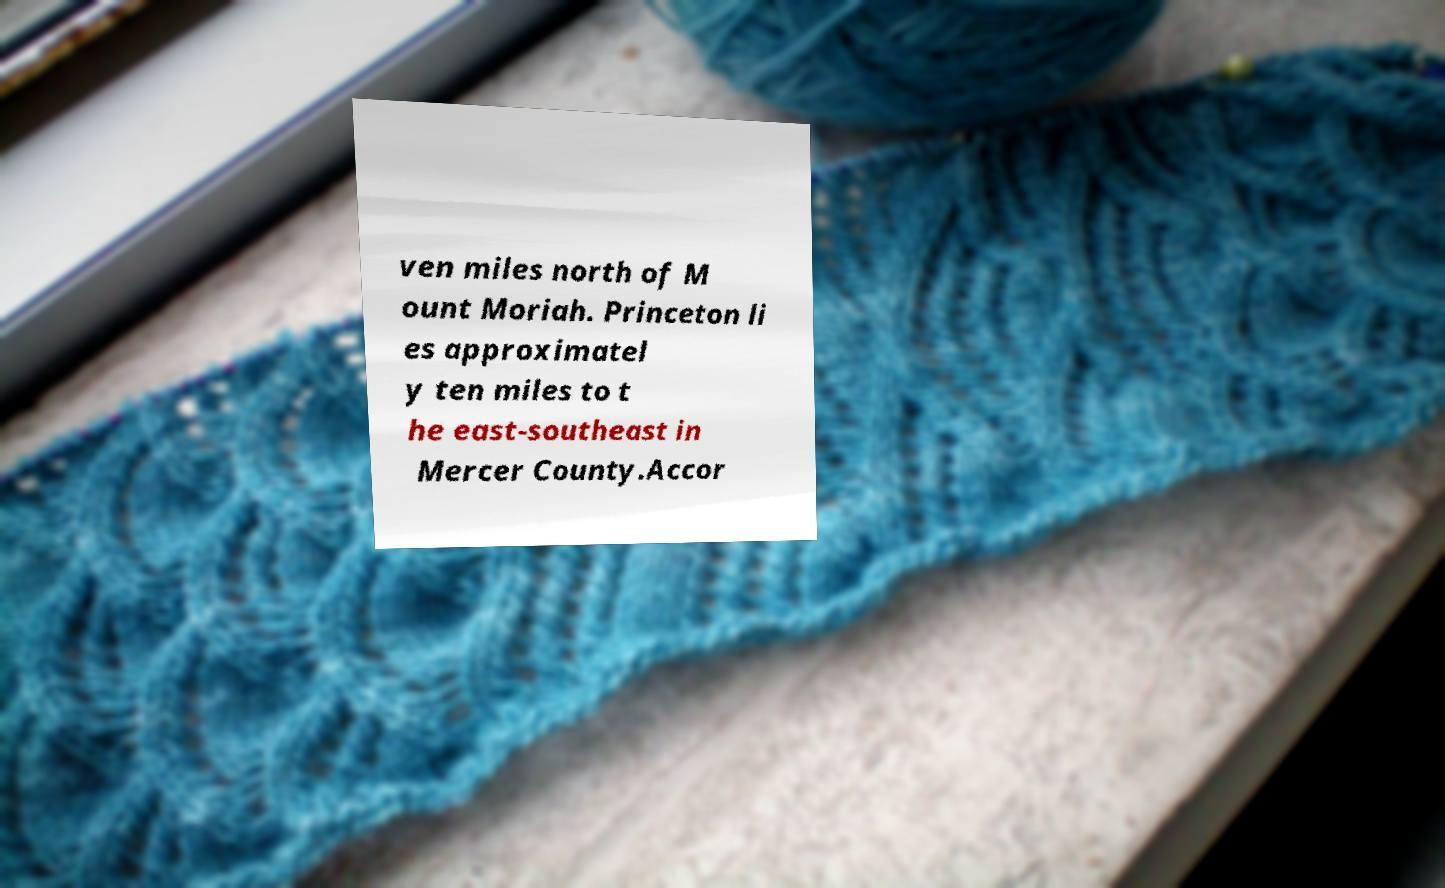Please read and relay the text visible in this image. What does it say? ven miles north of M ount Moriah. Princeton li es approximatel y ten miles to t he east-southeast in Mercer County.Accor 